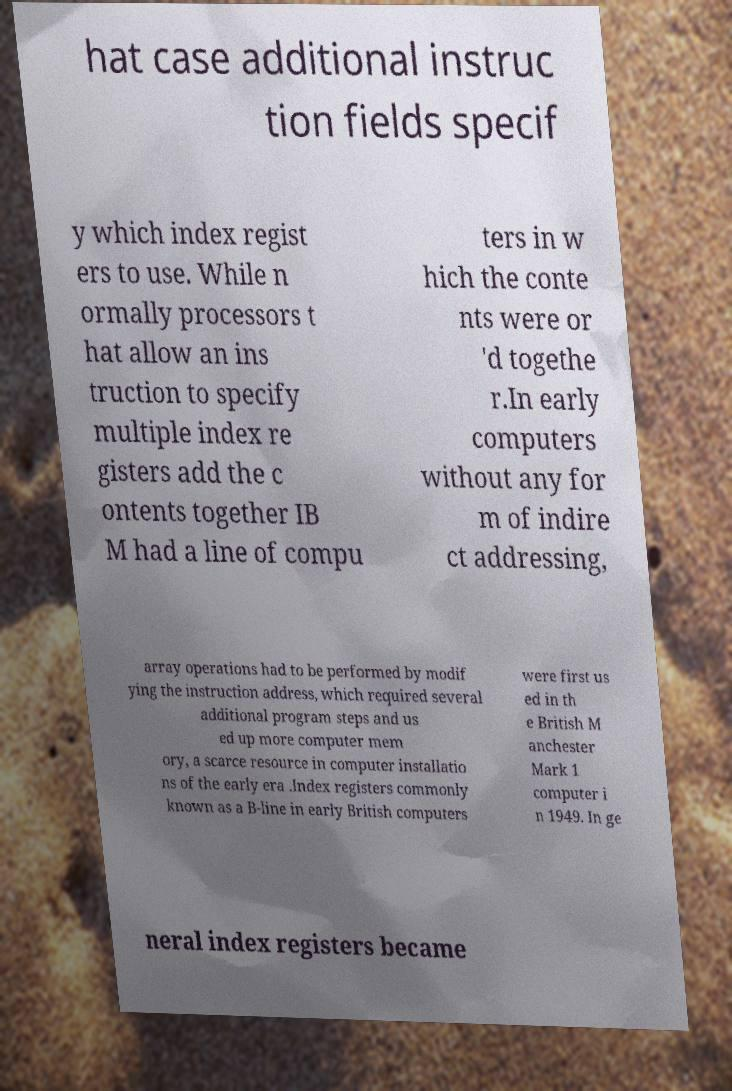There's text embedded in this image that I need extracted. Can you transcribe it verbatim? hat case additional instruc tion fields specif y which index regist ers to use. While n ormally processors t hat allow an ins truction to specify multiple index re gisters add the c ontents together IB M had a line of compu ters in w hich the conte nts were or 'd togethe r.In early computers without any for m of indire ct addressing, array operations had to be performed by modif ying the instruction address, which required several additional program steps and us ed up more computer mem ory, a scarce resource in computer installatio ns of the early era .Index registers commonly known as a B-line in early British computers were first us ed in th e British M anchester Mark 1 computer i n 1949. In ge neral index registers became 